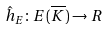Convert formula to latex. <formula><loc_0><loc_0><loc_500><loc_500>\hat { h } _ { E } \colon E ( \overline { K } ) \rightarrow R</formula> 